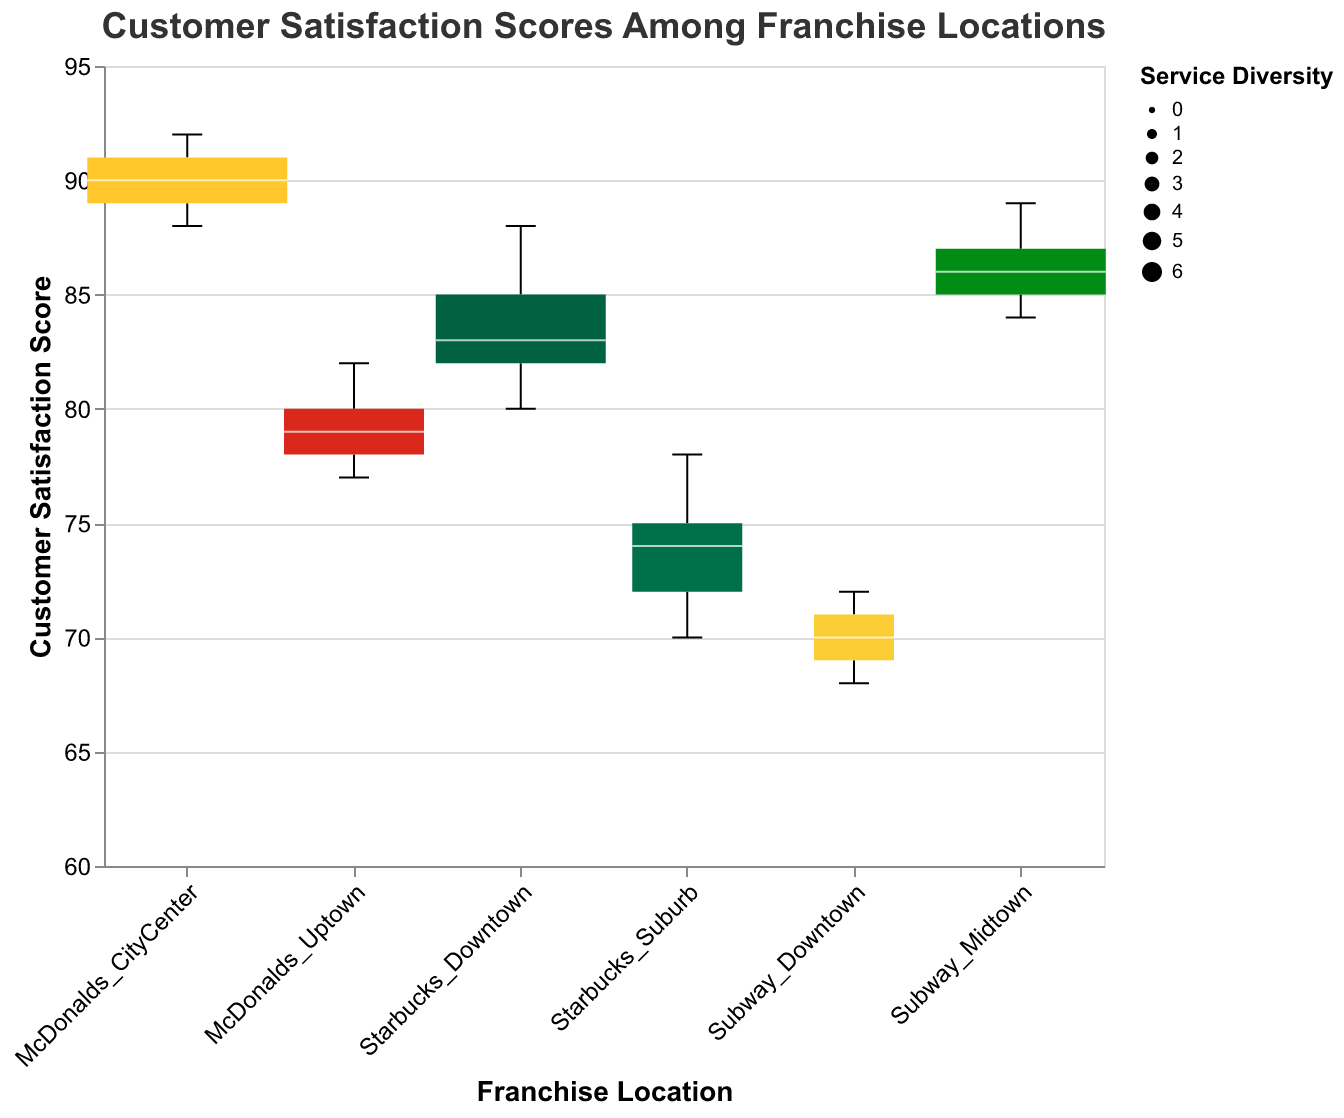What is the range of customer satisfaction scores for Starbucks Downtown? The range of customer satisfaction scores for Starbucks Downtown can be found by identifying the minimum and maximum values in the box plot for this location. Starbuck's Downtown scores range from 80 to 88.
Answer: 80 to 88 Which franchise location has the highest median customer satisfaction score? To determine the franchise location with the highest median customer satisfaction score, locate the median line within each box plot. McDonald's City Center has the highest median score among the displayed locations.
Answer: McDonald's City Center How does the customer satisfaction score distribution of Subway Midtown compare to Subway Downtown? Subway Midtown has customer satisfaction scores ranging from 84 to 89, showing a higher range than Subway Downtown which has scores between 68 and 72. The distribution for Midtown is also more compact and higher on the scale.
Answer: Midtown vs Downtown: 84-89 higher than 68-72 Which franchise location provides the widest variety of services, and what is its median satisfaction score? The franchise with the widest box (widest service diversity) on the plot is McDonald's City Center. The median satisfaction score for this location can be identified from the line within the box, which is 90.
Answer: McDonald's City Center, 90 What is the service diversity of Starbucks Suburb, and how does its score distribution compare to Subway Downtown? Starbucks Suburb has a service diversity of 3, visible from the width of the box. Comparing distributions: Starbucks Suburb ranges are higher from 70 to 78 compared to Subway Downtown's range of 68 to 72.
Answer: 3, Starbucks Suburb: 70-78 > Subway Downtown: 68-72 Which two franchises have the same service diversity but different ranges of customer satisfaction scores? To identify, look for the same width of the boxes. Both Subway Midtown and Starbucks Downtown have a service diversity of 5, but Subway Midtown scores range from 84 to 89 while Starbucks Downtown ranges from 80 to 88.
Answer: Subway Midtown and Starbucks Downtown What is the customer satisfaction score range for McDonald's Uptown? The box plot for McDonald's Uptown shows that customer satisfaction ranges from 77 to 82.
Answer: 77 to 82 Which franchise location has the least diversity in services and what is its satisfaction score range? By observing the smallest width of the boxes representing service diversity, Subway Downtown has the least diversity of services (width 2). Its customer satisfaction scores range from 68 to 72.
Answer: Subway Downtown, 68 to 72 